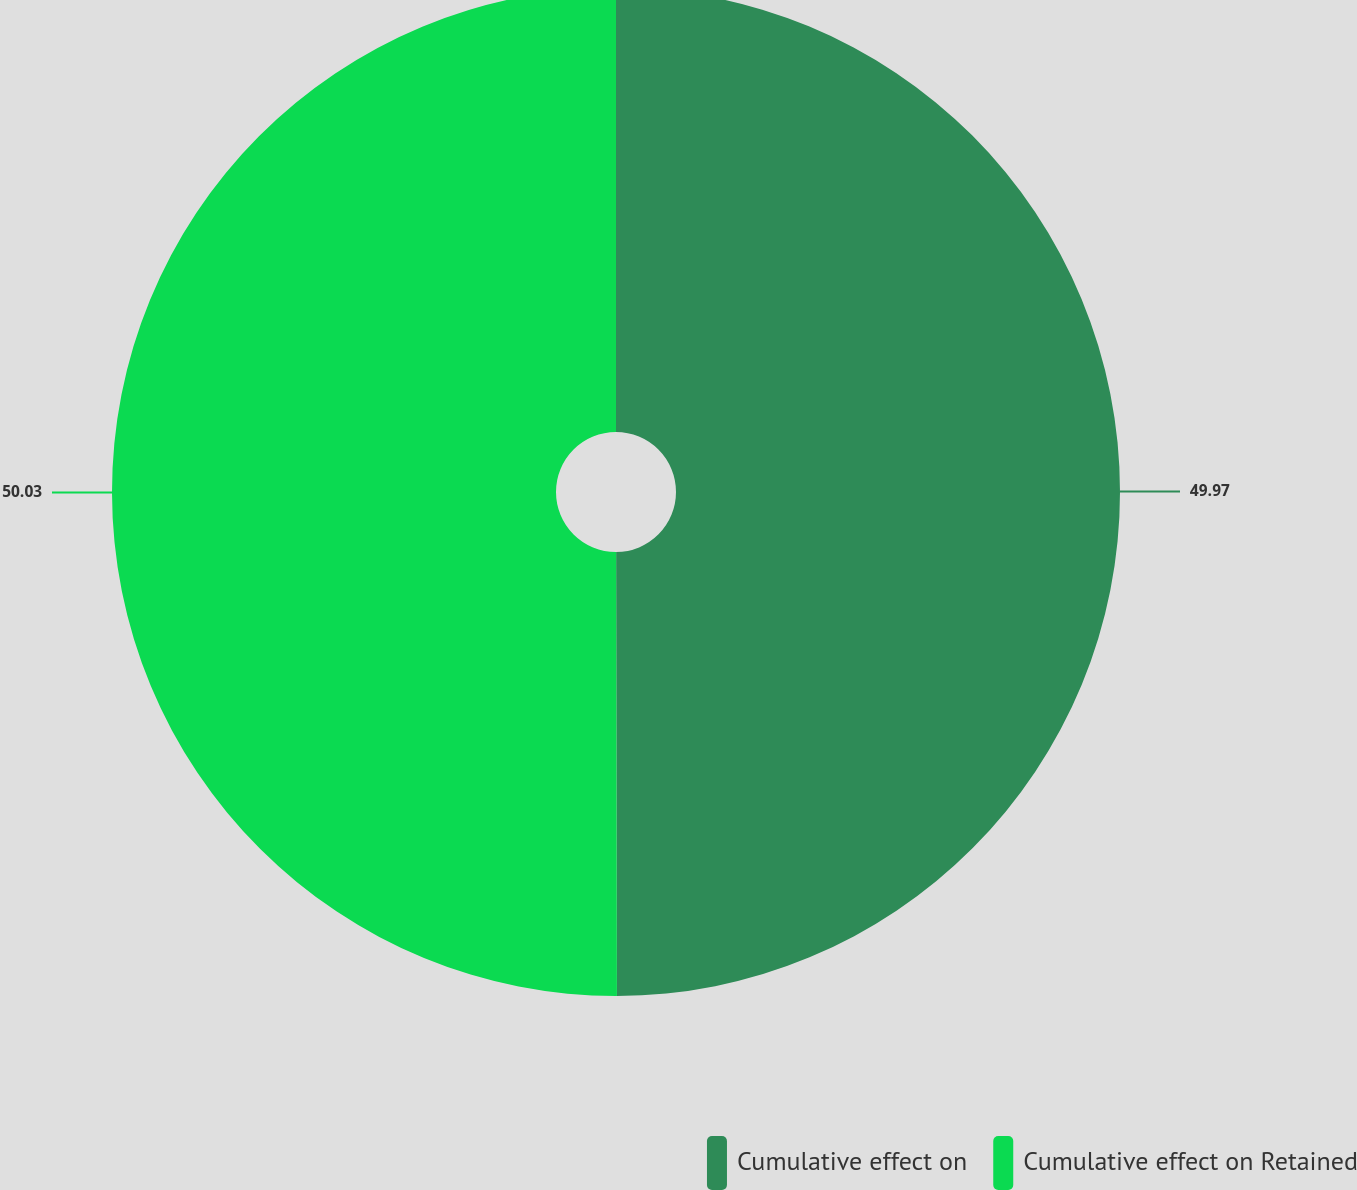<chart> <loc_0><loc_0><loc_500><loc_500><pie_chart><fcel>Cumulative effect on<fcel>Cumulative effect on Retained<nl><fcel>49.97%<fcel>50.03%<nl></chart> 